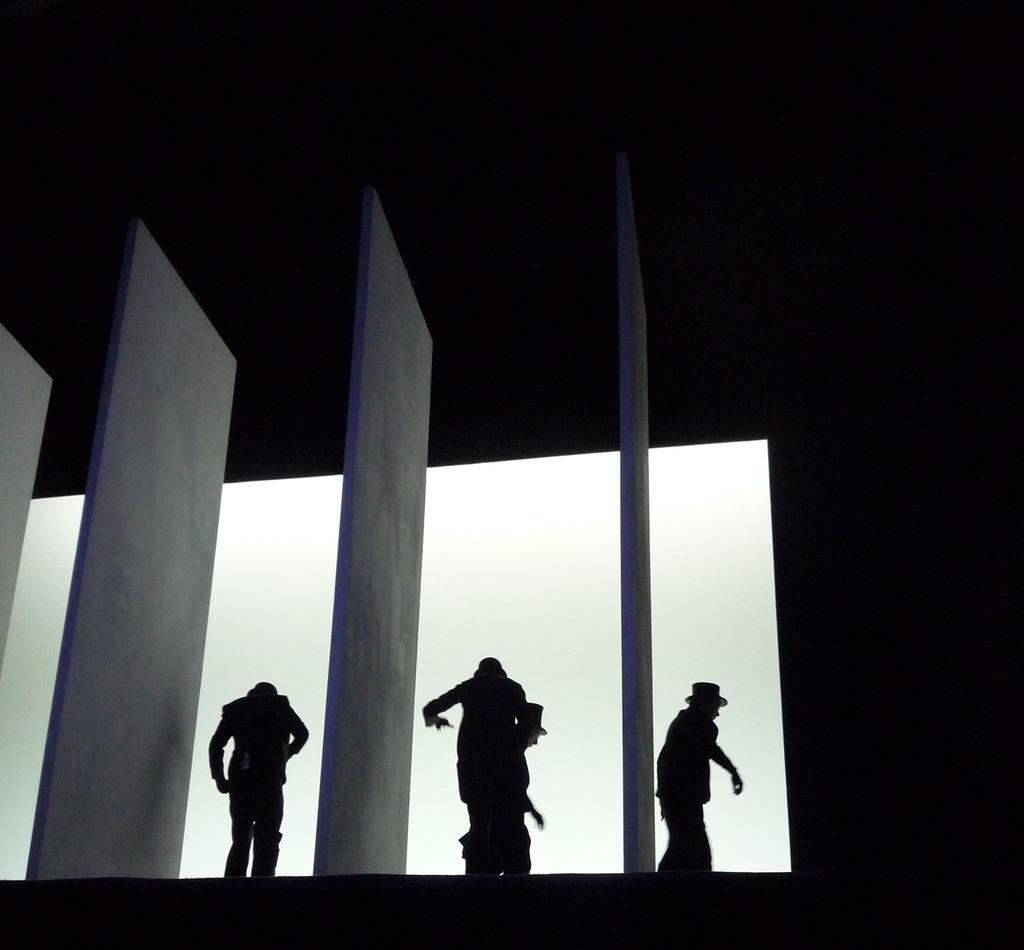Can you describe this image briefly? In the center of the image there are four person. At the right side of the image there is a wall. 